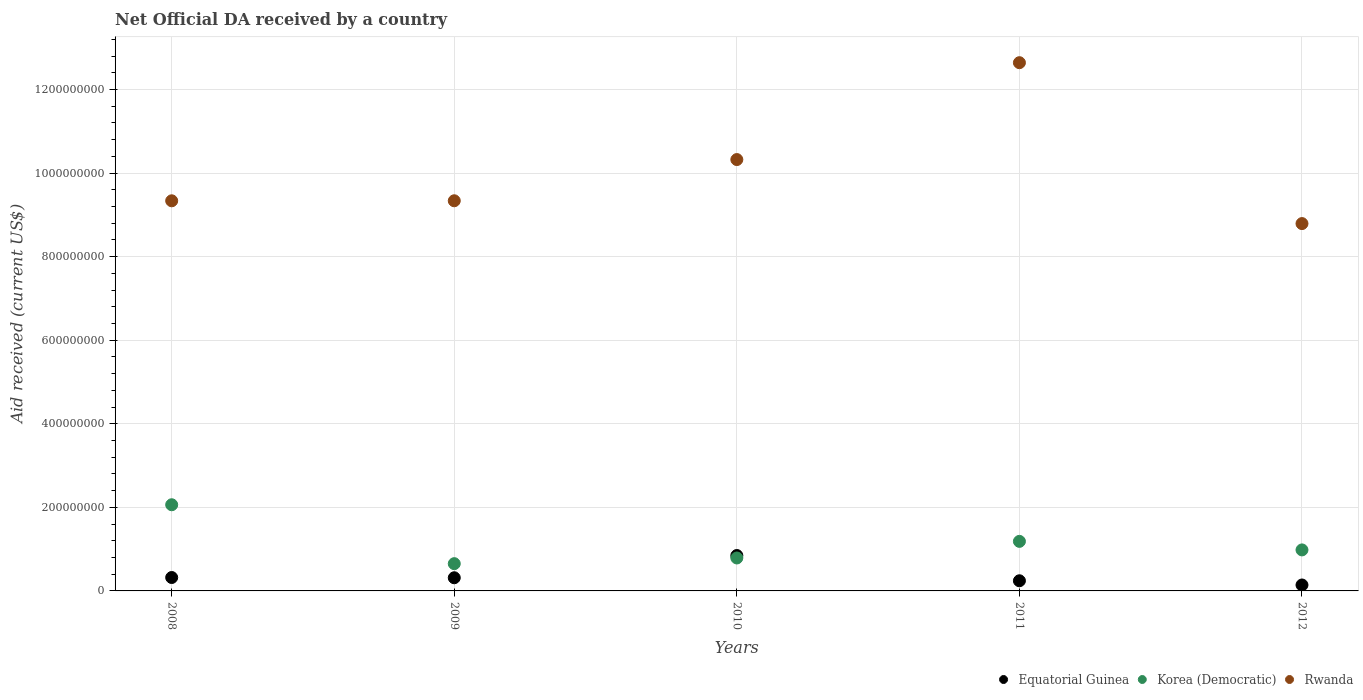What is the net official development assistance aid received in Equatorial Guinea in 2008?
Offer a terse response. 3.21e+07. Across all years, what is the maximum net official development assistance aid received in Rwanda?
Your response must be concise. 1.26e+09. Across all years, what is the minimum net official development assistance aid received in Rwanda?
Your response must be concise. 8.79e+08. In which year was the net official development assistance aid received in Equatorial Guinea maximum?
Provide a succinct answer. 2010. In which year was the net official development assistance aid received in Equatorial Guinea minimum?
Your answer should be compact. 2012. What is the total net official development assistance aid received in Rwanda in the graph?
Make the answer very short. 5.04e+09. What is the difference between the net official development assistance aid received in Rwanda in 2010 and that in 2011?
Your answer should be very brief. -2.32e+08. What is the difference between the net official development assistance aid received in Equatorial Guinea in 2008 and the net official development assistance aid received in Korea (Democratic) in 2012?
Ensure brevity in your answer.  -6.61e+07. What is the average net official development assistance aid received in Korea (Democratic) per year?
Provide a succinct answer. 1.13e+08. In the year 2010, what is the difference between the net official development assistance aid received in Korea (Democratic) and net official development assistance aid received in Equatorial Guinea?
Your answer should be very brief. -5.87e+06. What is the ratio of the net official development assistance aid received in Rwanda in 2009 to that in 2012?
Make the answer very short. 1.06. What is the difference between the highest and the second highest net official development assistance aid received in Equatorial Guinea?
Provide a short and direct response. 5.26e+07. What is the difference between the highest and the lowest net official development assistance aid received in Equatorial Guinea?
Ensure brevity in your answer.  7.05e+07. In how many years, is the net official development assistance aid received in Equatorial Guinea greater than the average net official development assistance aid received in Equatorial Guinea taken over all years?
Your answer should be very brief. 1. Is it the case that in every year, the sum of the net official development assistance aid received in Equatorial Guinea and net official development assistance aid received in Rwanda  is greater than the net official development assistance aid received in Korea (Democratic)?
Give a very brief answer. Yes. Does the net official development assistance aid received in Equatorial Guinea monotonically increase over the years?
Your response must be concise. No. Is the net official development assistance aid received in Equatorial Guinea strictly greater than the net official development assistance aid received in Rwanda over the years?
Provide a succinct answer. No. Is the net official development assistance aid received in Korea (Democratic) strictly less than the net official development assistance aid received in Rwanda over the years?
Ensure brevity in your answer.  Yes. How many dotlines are there?
Your answer should be compact. 3. Does the graph contain any zero values?
Offer a very short reply. No. How are the legend labels stacked?
Your answer should be compact. Horizontal. What is the title of the graph?
Provide a succinct answer. Net Official DA received by a country. What is the label or title of the X-axis?
Ensure brevity in your answer.  Years. What is the label or title of the Y-axis?
Provide a short and direct response. Aid received (current US$). What is the Aid received (current US$) of Equatorial Guinea in 2008?
Offer a very short reply. 3.21e+07. What is the Aid received (current US$) in Korea (Democratic) in 2008?
Your answer should be very brief. 2.06e+08. What is the Aid received (current US$) in Rwanda in 2008?
Your answer should be compact. 9.34e+08. What is the Aid received (current US$) in Equatorial Guinea in 2009?
Your answer should be very brief. 3.15e+07. What is the Aid received (current US$) in Korea (Democratic) in 2009?
Provide a short and direct response. 6.52e+07. What is the Aid received (current US$) of Rwanda in 2009?
Give a very brief answer. 9.34e+08. What is the Aid received (current US$) of Equatorial Guinea in 2010?
Ensure brevity in your answer.  8.47e+07. What is the Aid received (current US$) of Korea (Democratic) in 2010?
Your response must be concise. 7.88e+07. What is the Aid received (current US$) in Rwanda in 2010?
Provide a short and direct response. 1.03e+09. What is the Aid received (current US$) in Equatorial Guinea in 2011?
Offer a very short reply. 2.43e+07. What is the Aid received (current US$) in Korea (Democratic) in 2011?
Your answer should be compact. 1.19e+08. What is the Aid received (current US$) of Rwanda in 2011?
Your response must be concise. 1.26e+09. What is the Aid received (current US$) of Equatorial Guinea in 2012?
Give a very brief answer. 1.42e+07. What is the Aid received (current US$) in Korea (Democratic) in 2012?
Give a very brief answer. 9.81e+07. What is the Aid received (current US$) in Rwanda in 2012?
Offer a terse response. 8.79e+08. Across all years, what is the maximum Aid received (current US$) of Equatorial Guinea?
Offer a very short reply. 8.47e+07. Across all years, what is the maximum Aid received (current US$) in Korea (Democratic)?
Your response must be concise. 2.06e+08. Across all years, what is the maximum Aid received (current US$) in Rwanda?
Keep it short and to the point. 1.26e+09. Across all years, what is the minimum Aid received (current US$) in Equatorial Guinea?
Give a very brief answer. 1.42e+07. Across all years, what is the minimum Aid received (current US$) in Korea (Democratic)?
Offer a terse response. 6.52e+07. Across all years, what is the minimum Aid received (current US$) of Rwanda?
Make the answer very short. 8.79e+08. What is the total Aid received (current US$) of Equatorial Guinea in the graph?
Offer a terse response. 1.87e+08. What is the total Aid received (current US$) in Korea (Democratic) in the graph?
Offer a terse response. 5.67e+08. What is the total Aid received (current US$) in Rwanda in the graph?
Give a very brief answer. 5.04e+09. What is the difference between the Aid received (current US$) of Equatorial Guinea in 2008 and that in 2009?
Offer a terse response. 5.90e+05. What is the difference between the Aid received (current US$) of Korea (Democratic) in 2008 and that in 2009?
Your answer should be very brief. 1.41e+08. What is the difference between the Aid received (current US$) of Rwanda in 2008 and that in 2009?
Offer a terse response. -8.00e+04. What is the difference between the Aid received (current US$) of Equatorial Guinea in 2008 and that in 2010?
Offer a very short reply. -5.26e+07. What is the difference between the Aid received (current US$) in Korea (Democratic) in 2008 and that in 2010?
Your answer should be very brief. 1.27e+08. What is the difference between the Aid received (current US$) in Rwanda in 2008 and that in 2010?
Offer a terse response. -9.87e+07. What is the difference between the Aid received (current US$) of Equatorial Guinea in 2008 and that in 2011?
Provide a short and direct response. 7.78e+06. What is the difference between the Aid received (current US$) in Korea (Democratic) in 2008 and that in 2011?
Your answer should be compact. 8.76e+07. What is the difference between the Aid received (current US$) of Rwanda in 2008 and that in 2011?
Offer a very short reply. -3.30e+08. What is the difference between the Aid received (current US$) in Equatorial Guinea in 2008 and that in 2012?
Give a very brief answer. 1.79e+07. What is the difference between the Aid received (current US$) in Korea (Democratic) in 2008 and that in 2012?
Your response must be concise. 1.08e+08. What is the difference between the Aid received (current US$) in Rwanda in 2008 and that in 2012?
Offer a very short reply. 5.45e+07. What is the difference between the Aid received (current US$) of Equatorial Guinea in 2009 and that in 2010?
Your response must be concise. -5.32e+07. What is the difference between the Aid received (current US$) in Korea (Democratic) in 2009 and that in 2010?
Provide a succinct answer. -1.36e+07. What is the difference between the Aid received (current US$) of Rwanda in 2009 and that in 2010?
Ensure brevity in your answer.  -9.86e+07. What is the difference between the Aid received (current US$) of Equatorial Guinea in 2009 and that in 2011?
Your answer should be very brief. 7.19e+06. What is the difference between the Aid received (current US$) in Korea (Democratic) in 2009 and that in 2011?
Ensure brevity in your answer.  -5.34e+07. What is the difference between the Aid received (current US$) of Rwanda in 2009 and that in 2011?
Provide a short and direct response. -3.30e+08. What is the difference between the Aid received (current US$) of Equatorial Guinea in 2009 and that in 2012?
Give a very brief answer. 1.73e+07. What is the difference between the Aid received (current US$) in Korea (Democratic) in 2009 and that in 2012?
Your answer should be compact. -3.29e+07. What is the difference between the Aid received (current US$) in Rwanda in 2009 and that in 2012?
Your response must be concise. 5.46e+07. What is the difference between the Aid received (current US$) in Equatorial Guinea in 2010 and that in 2011?
Ensure brevity in your answer.  6.04e+07. What is the difference between the Aid received (current US$) of Korea (Democratic) in 2010 and that in 2011?
Provide a succinct answer. -3.97e+07. What is the difference between the Aid received (current US$) in Rwanda in 2010 and that in 2011?
Your response must be concise. -2.32e+08. What is the difference between the Aid received (current US$) in Equatorial Guinea in 2010 and that in 2012?
Your answer should be compact. 7.05e+07. What is the difference between the Aid received (current US$) in Korea (Democratic) in 2010 and that in 2012?
Your response must be concise. -1.93e+07. What is the difference between the Aid received (current US$) of Rwanda in 2010 and that in 2012?
Keep it short and to the point. 1.53e+08. What is the difference between the Aid received (current US$) in Equatorial Guinea in 2011 and that in 2012?
Ensure brevity in your answer.  1.01e+07. What is the difference between the Aid received (current US$) in Korea (Democratic) in 2011 and that in 2012?
Offer a very short reply. 2.04e+07. What is the difference between the Aid received (current US$) of Rwanda in 2011 and that in 2012?
Offer a terse response. 3.85e+08. What is the difference between the Aid received (current US$) of Equatorial Guinea in 2008 and the Aid received (current US$) of Korea (Democratic) in 2009?
Give a very brief answer. -3.31e+07. What is the difference between the Aid received (current US$) in Equatorial Guinea in 2008 and the Aid received (current US$) in Rwanda in 2009?
Provide a succinct answer. -9.02e+08. What is the difference between the Aid received (current US$) of Korea (Democratic) in 2008 and the Aid received (current US$) of Rwanda in 2009?
Make the answer very short. -7.27e+08. What is the difference between the Aid received (current US$) of Equatorial Guinea in 2008 and the Aid received (current US$) of Korea (Democratic) in 2010?
Provide a succinct answer. -4.68e+07. What is the difference between the Aid received (current US$) of Equatorial Guinea in 2008 and the Aid received (current US$) of Rwanda in 2010?
Give a very brief answer. -1.00e+09. What is the difference between the Aid received (current US$) of Korea (Democratic) in 2008 and the Aid received (current US$) of Rwanda in 2010?
Give a very brief answer. -8.26e+08. What is the difference between the Aid received (current US$) of Equatorial Guinea in 2008 and the Aid received (current US$) of Korea (Democratic) in 2011?
Keep it short and to the point. -8.65e+07. What is the difference between the Aid received (current US$) of Equatorial Guinea in 2008 and the Aid received (current US$) of Rwanda in 2011?
Your response must be concise. -1.23e+09. What is the difference between the Aid received (current US$) in Korea (Democratic) in 2008 and the Aid received (current US$) in Rwanda in 2011?
Your answer should be very brief. -1.06e+09. What is the difference between the Aid received (current US$) in Equatorial Guinea in 2008 and the Aid received (current US$) in Korea (Democratic) in 2012?
Offer a very short reply. -6.61e+07. What is the difference between the Aid received (current US$) of Equatorial Guinea in 2008 and the Aid received (current US$) of Rwanda in 2012?
Your answer should be compact. -8.47e+08. What is the difference between the Aid received (current US$) of Korea (Democratic) in 2008 and the Aid received (current US$) of Rwanda in 2012?
Ensure brevity in your answer.  -6.73e+08. What is the difference between the Aid received (current US$) of Equatorial Guinea in 2009 and the Aid received (current US$) of Korea (Democratic) in 2010?
Offer a terse response. -4.74e+07. What is the difference between the Aid received (current US$) of Equatorial Guinea in 2009 and the Aid received (current US$) of Rwanda in 2010?
Your answer should be very brief. -1.00e+09. What is the difference between the Aid received (current US$) in Korea (Democratic) in 2009 and the Aid received (current US$) in Rwanda in 2010?
Ensure brevity in your answer.  -9.67e+08. What is the difference between the Aid received (current US$) in Equatorial Guinea in 2009 and the Aid received (current US$) in Korea (Democratic) in 2011?
Offer a very short reply. -8.71e+07. What is the difference between the Aid received (current US$) in Equatorial Guinea in 2009 and the Aid received (current US$) in Rwanda in 2011?
Your answer should be compact. -1.23e+09. What is the difference between the Aid received (current US$) in Korea (Democratic) in 2009 and the Aid received (current US$) in Rwanda in 2011?
Provide a short and direct response. -1.20e+09. What is the difference between the Aid received (current US$) in Equatorial Guinea in 2009 and the Aid received (current US$) in Korea (Democratic) in 2012?
Make the answer very short. -6.66e+07. What is the difference between the Aid received (current US$) of Equatorial Guinea in 2009 and the Aid received (current US$) of Rwanda in 2012?
Provide a short and direct response. -8.48e+08. What is the difference between the Aid received (current US$) in Korea (Democratic) in 2009 and the Aid received (current US$) in Rwanda in 2012?
Ensure brevity in your answer.  -8.14e+08. What is the difference between the Aid received (current US$) in Equatorial Guinea in 2010 and the Aid received (current US$) in Korea (Democratic) in 2011?
Provide a short and direct response. -3.39e+07. What is the difference between the Aid received (current US$) of Equatorial Guinea in 2010 and the Aid received (current US$) of Rwanda in 2011?
Make the answer very short. -1.18e+09. What is the difference between the Aid received (current US$) of Korea (Democratic) in 2010 and the Aid received (current US$) of Rwanda in 2011?
Provide a succinct answer. -1.19e+09. What is the difference between the Aid received (current US$) in Equatorial Guinea in 2010 and the Aid received (current US$) in Korea (Democratic) in 2012?
Offer a terse response. -1.34e+07. What is the difference between the Aid received (current US$) in Equatorial Guinea in 2010 and the Aid received (current US$) in Rwanda in 2012?
Provide a short and direct response. -7.94e+08. What is the difference between the Aid received (current US$) of Korea (Democratic) in 2010 and the Aid received (current US$) of Rwanda in 2012?
Offer a very short reply. -8.00e+08. What is the difference between the Aid received (current US$) in Equatorial Guinea in 2011 and the Aid received (current US$) in Korea (Democratic) in 2012?
Offer a very short reply. -7.38e+07. What is the difference between the Aid received (current US$) in Equatorial Guinea in 2011 and the Aid received (current US$) in Rwanda in 2012?
Offer a very short reply. -8.55e+08. What is the difference between the Aid received (current US$) of Korea (Democratic) in 2011 and the Aid received (current US$) of Rwanda in 2012?
Provide a succinct answer. -7.60e+08. What is the average Aid received (current US$) in Equatorial Guinea per year?
Keep it short and to the point. 3.74e+07. What is the average Aid received (current US$) in Korea (Democratic) per year?
Offer a very short reply. 1.13e+08. What is the average Aid received (current US$) in Rwanda per year?
Keep it short and to the point. 1.01e+09. In the year 2008, what is the difference between the Aid received (current US$) in Equatorial Guinea and Aid received (current US$) in Korea (Democratic)?
Your answer should be compact. -1.74e+08. In the year 2008, what is the difference between the Aid received (current US$) in Equatorial Guinea and Aid received (current US$) in Rwanda?
Keep it short and to the point. -9.01e+08. In the year 2008, what is the difference between the Aid received (current US$) in Korea (Democratic) and Aid received (current US$) in Rwanda?
Provide a short and direct response. -7.27e+08. In the year 2009, what is the difference between the Aid received (current US$) of Equatorial Guinea and Aid received (current US$) of Korea (Democratic)?
Your response must be concise. -3.37e+07. In the year 2009, what is the difference between the Aid received (current US$) of Equatorial Guinea and Aid received (current US$) of Rwanda?
Keep it short and to the point. -9.02e+08. In the year 2009, what is the difference between the Aid received (current US$) in Korea (Democratic) and Aid received (current US$) in Rwanda?
Provide a short and direct response. -8.68e+08. In the year 2010, what is the difference between the Aid received (current US$) in Equatorial Guinea and Aid received (current US$) in Korea (Democratic)?
Your answer should be very brief. 5.87e+06. In the year 2010, what is the difference between the Aid received (current US$) of Equatorial Guinea and Aid received (current US$) of Rwanda?
Offer a very short reply. -9.47e+08. In the year 2010, what is the difference between the Aid received (current US$) of Korea (Democratic) and Aid received (current US$) of Rwanda?
Your response must be concise. -9.53e+08. In the year 2011, what is the difference between the Aid received (current US$) in Equatorial Guinea and Aid received (current US$) in Korea (Democratic)?
Your answer should be compact. -9.43e+07. In the year 2011, what is the difference between the Aid received (current US$) of Equatorial Guinea and Aid received (current US$) of Rwanda?
Make the answer very short. -1.24e+09. In the year 2011, what is the difference between the Aid received (current US$) in Korea (Democratic) and Aid received (current US$) in Rwanda?
Your answer should be very brief. -1.15e+09. In the year 2012, what is the difference between the Aid received (current US$) in Equatorial Guinea and Aid received (current US$) in Korea (Democratic)?
Give a very brief answer. -8.39e+07. In the year 2012, what is the difference between the Aid received (current US$) in Equatorial Guinea and Aid received (current US$) in Rwanda?
Make the answer very short. -8.65e+08. In the year 2012, what is the difference between the Aid received (current US$) in Korea (Democratic) and Aid received (current US$) in Rwanda?
Offer a very short reply. -7.81e+08. What is the ratio of the Aid received (current US$) in Equatorial Guinea in 2008 to that in 2009?
Keep it short and to the point. 1.02. What is the ratio of the Aid received (current US$) of Korea (Democratic) in 2008 to that in 2009?
Give a very brief answer. 3.16. What is the ratio of the Aid received (current US$) in Equatorial Guinea in 2008 to that in 2010?
Your answer should be compact. 0.38. What is the ratio of the Aid received (current US$) of Korea (Democratic) in 2008 to that in 2010?
Your response must be concise. 2.62. What is the ratio of the Aid received (current US$) of Rwanda in 2008 to that in 2010?
Your response must be concise. 0.9. What is the ratio of the Aid received (current US$) of Equatorial Guinea in 2008 to that in 2011?
Make the answer very short. 1.32. What is the ratio of the Aid received (current US$) in Korea (Democratic) in 2008 to that in 2011?
Make the answer very short. 1.74. What is the ratio of the Aid received (current US$) in Rwanda in 2008 to that in 2011?
Your answer should be compact. 0.74. What is the ratio of the Aid received (current US$) of Equatorial Guinea in 2008 to that in 2012?
Offer a terse response. 2.26. What is the ratio of the Aid received (current US$) in Korea (Democratic) in 2008 to that in 2012?
Offer a very short reply. 2.1. What is the ratio of the Aid received (current US$) in Rwanda in 2008 to that in 2012?
Offer a terse response. 1.06. What is the ratio of the Aid received (current US$) of Equatorial Guinea in 2009 to that in 2010?
Your answer should be compact. 0.37. What is the ratio of the Aid received (current US$) of Korea (Democratic) in 2009 to that in 2010?
Provide a succinct answer. 0.83. What is the ratio of the Aid received (current US$) of Rwanda in 2009 to that in 2010?
Provide a succinct answer. 0.9. What is the ratio of the Aid received (current US$) in Equatorial Guinea in 2009 to that in 2011?
Provide a succinct answer. 1.3. What is the ratio of the Aid received (current US$) in Korea (Democratic) in 2009 to that in 2011?
Offer a terse response. 0.55. What is the ratio of the Aid received (current US$) in Rwanda in 2009 to that in 2011?
Give a very brief answer. 0.74. What is the ratio of the Aid received (current US$) in Equatorial Guinea in 2009 to that in 2012?
Your response must be concise. 2.22. What is the ratio of the Aid received (current US$) of Korea (Democratic) in 2009 to that in 2012?
Your answer should be very brief. 0.66. What is the ratio of the Aid received (current US$) of Rwanda in 2009 to that in 2012?
Provide a short and direct response. 1.06. What is the ratio of the Aid received (current US$) in Equatorial Guinea in 2010 to that in 2011?
Your response must be concise. 3.49. What is the ratio of the Aid received (current US$) of Korea (Democratic) in 2010 to that in 2011?
Give a very brief answer. 0.66. What is the ratio of the Aid received (current US$) in Rwanda in 2010 to that in 2011?
Offer a very short reply. 0.82. What is the ratio of the Aid received (current US$) in Equatorial Guinea in 2010 to that in 2012?
Your answer should be compact. 5.97. What is the ratio of the Aid received (current US$) of Korea (Democratic) in 2010 to that in 2012?
Your answer should be compact. 0.8. What is the ratio of the Aid received (current US$) of Rwanda in 2010 to that in 2012?
Your answer should be very brief. 1.17. What is the ratio of the Aid received (current US$) in Equatorial Guinea in 2011 to that in 2012?
Your answer should be compact. 1.71. What is the ratio of the Aid received (current US$) in Korea (Democratic) in 2011 to that in 2012?
Provide a succinct answer. 1.21. What is the ratio of the Aid received (current US$) of Rwanda in 2011 to that in 2012?
Offer a terse response. 1.44. What is the difference between the highest and the second highest Aid received (current US$) in Equatorial Guinea?
Offer a terse response. 5.26e+07. What is the difference between the highest and the second highest Aid received (current US$) of Korea (Democratic)?
Provide a succinct answer. 8.76e+07. What is the difference between the highest and the second highest Aid received (current US$) in Rwanda?
Your response must be concise. 2.32e+08. What is the difference between the highest and the lowest Aid received (current US$) in Equatorial Guinea?
Give a very brief answer. 7.05e+07. What is the difference between the highest and the lowest Aid received (current US$) in Korea (Democratic)?
Give a very brief answer. 1.41e+08. What is the difference between the highest and the lowest Aid received (current US$) in Rwanda?
Provide a short and direct response. 3.85e+08. 